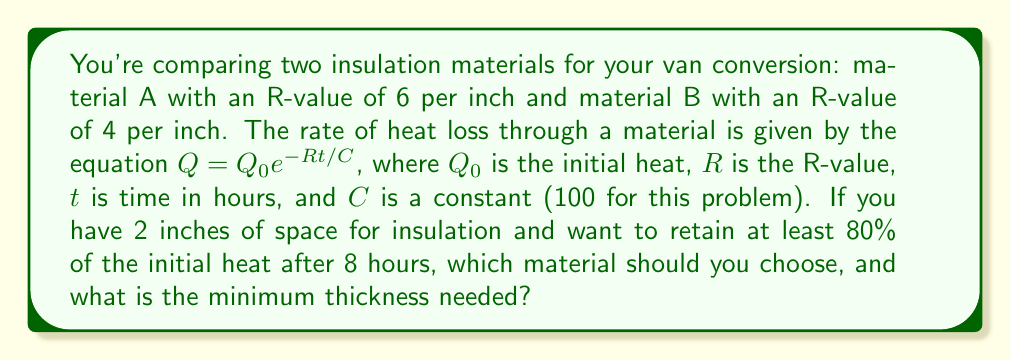Give your solution to this math problem. Let's approach this step-by-step:

1) We need to use the equation $Q = Q_0 e^{-Rt/C}$ where:
   $Q/Q_0 = 0.80$ (we want to retain 80% of initial heat)
   $t = 8$ hours
   $C = 100$ (given constant)

2) Let's solve for the required R-value:

   $0.80 = e^{-R(8)/100}$
   $\ln(0.80) = -R(8)/100$
   $R = -\ln(0.80) * 100 / 8 \approx 2.78$

3) Now, let's calculate the R-value for 2 inches of each material:
   Material A: $6 * 2 = 12$
   Material B: $4 * 2 = 8$

4) Both materials exceed the minimum R-value of 2.78 when used at 2 inches thickness.

5) To find the minimum thickness, let's divide the required R-value by the R-value per inch:
   Material A: $2.78 / 6 \approx 0.46$ inches
   Material B: $2.78 / 4 \approx 0.70$ inches

Therefore, Material A is more cost-effective as it requires less thickness to achieve the same insulation performance.
Answer: Material A, 0.46 inches 